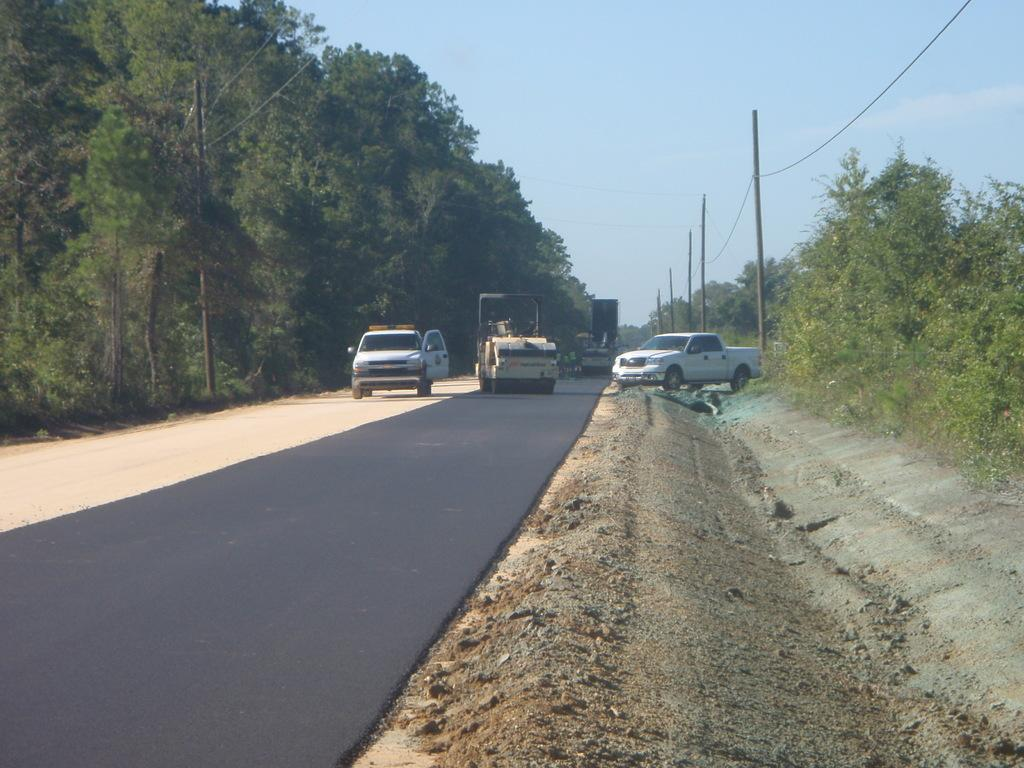What can be seen on the road in the image? There are vehicles on the road in the image. What type of natural elements are visible in the background of the image? There are trees in the background of the image. What else can be seen in the background of the image besides trees? There are poles in the background of the image. What is visible above the background elements in the image? The sky is visible in the background of the image. What type of thread is being used to decorate the holiday scene in the image? There is no holiday scene or thread present in the image; it features vehicles on a road with trees, poles, and the sky in the background. 